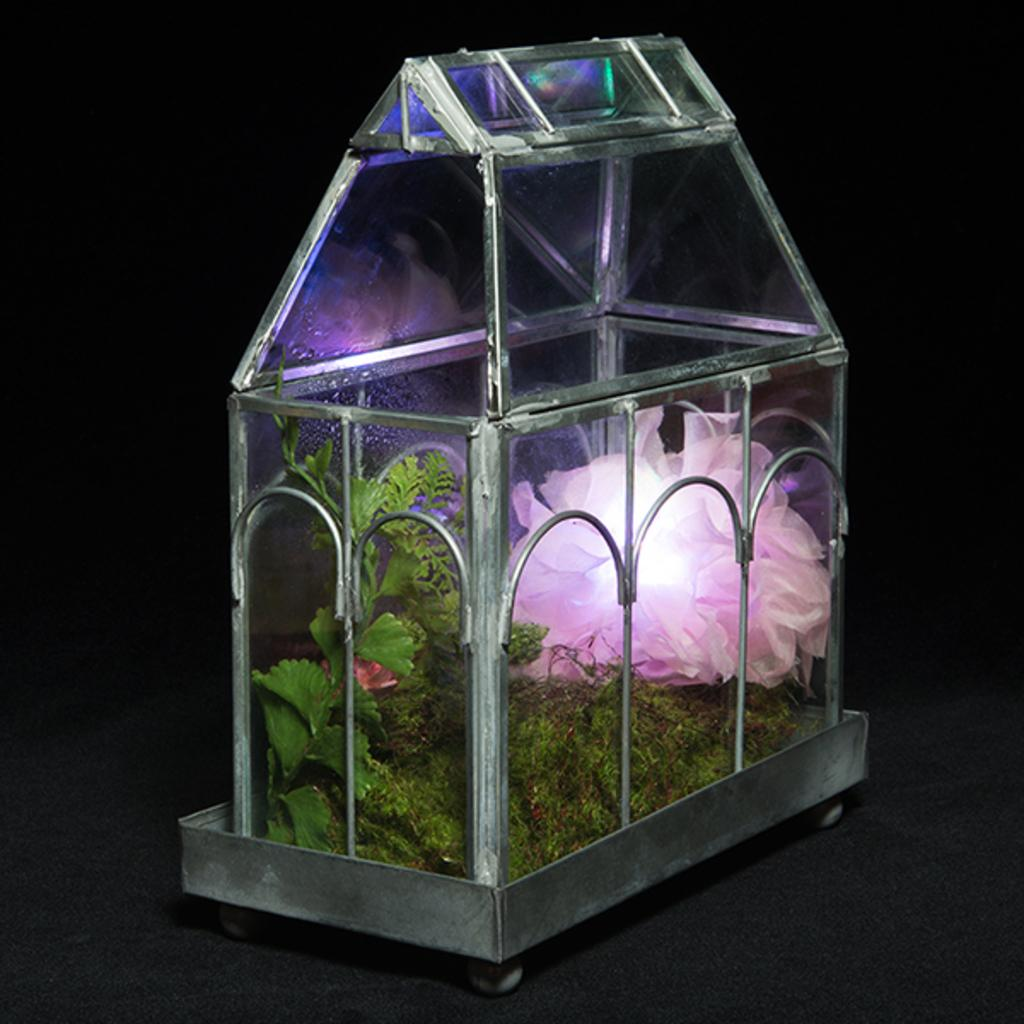What type of plant can be seen in the image? There is a plant with a flower in the image. What type of vegetation is present in the image? There is grass in the image. What can be seen providing illumination in the image? There is a light in the image. What is the pink color item placed in? The pink color item is placed in a glass box in the image. How is the glass box positioned in the image? The glass box is placed on a platform in the image. What decorative features are present on the glass box? There are designs on the glass box in the image. How many buildings can be seen in the image? There are no buildings present in the image. What type of lock is used to secure the glass box in the image? There is no lock present on the glass box in the image. 